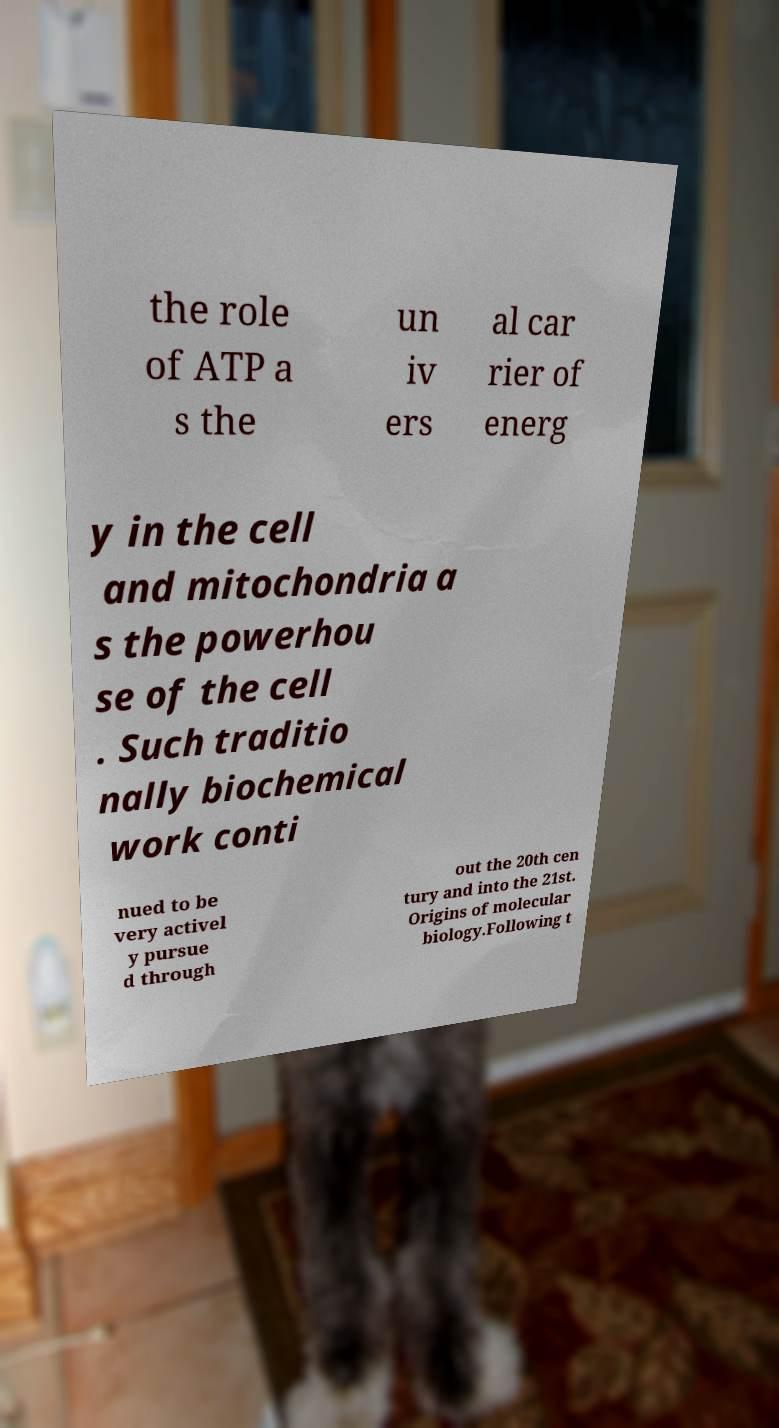Could you assist in decoding the text presented in this image and type it out clearly? the role of ATP a s the un iv ers al car rier of energ y in the cell and mitochondria a s the powerhou se of the cell . Such traditio nally biochemical work conti nued to be very activel y pursue d through out the 20th cen tury and into the 21st. Origins of molecular biology.Following t 